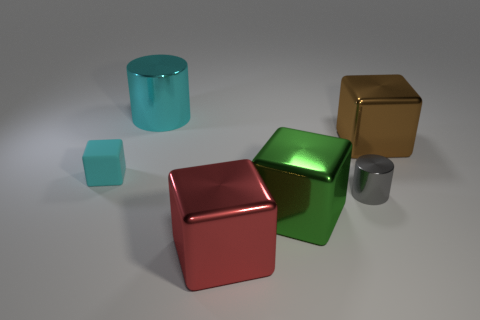Can you tell me about the shapes and materials of the objects? Certainly! There are five objects in the image, each with a different shape and material finish. Starting from the left, we have a large cyan cylinder with a rubber-like texture. Next is a small teal cube with a matte surface, followed by a large red cube that appears metallic. In the center is a large green cube with a polished, reflective surface, and on the far right, there's a small golden cube with a shiny metal finish. 